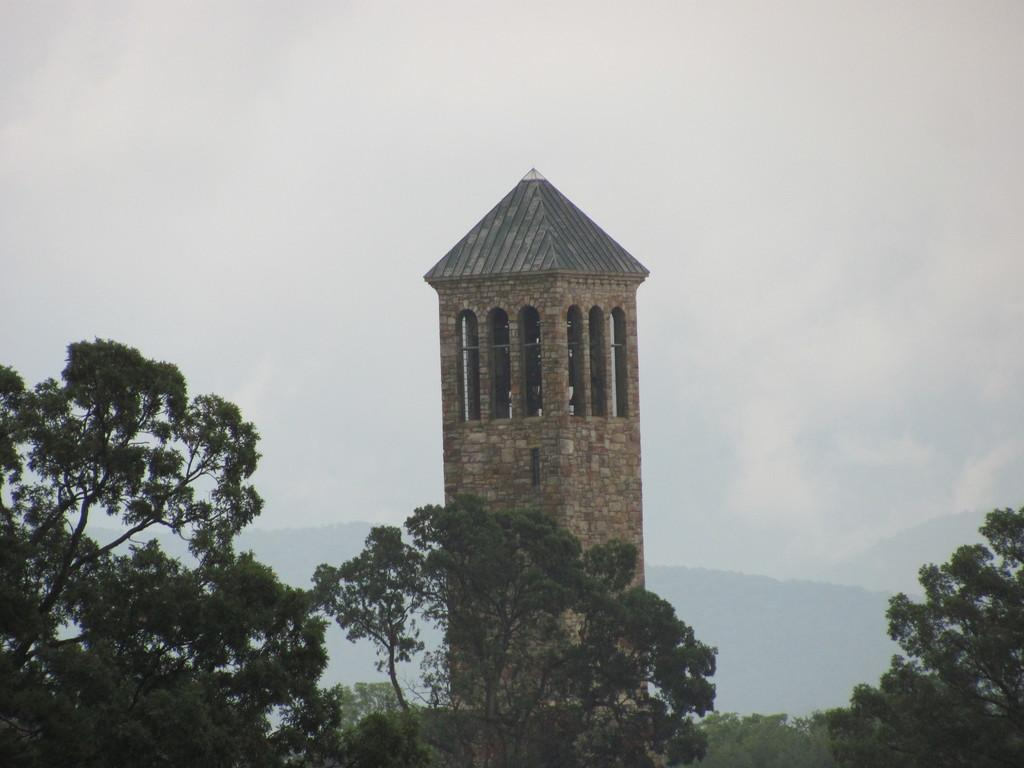What is the main subject in the middle of the image? There is a structure in the middle of the image. What type of vegetation can be seen on the left side of the image? There are trees on the left side of the image. What type of appliance can be seen on the right side of the image? There is no appliance present on the right side of the image. 